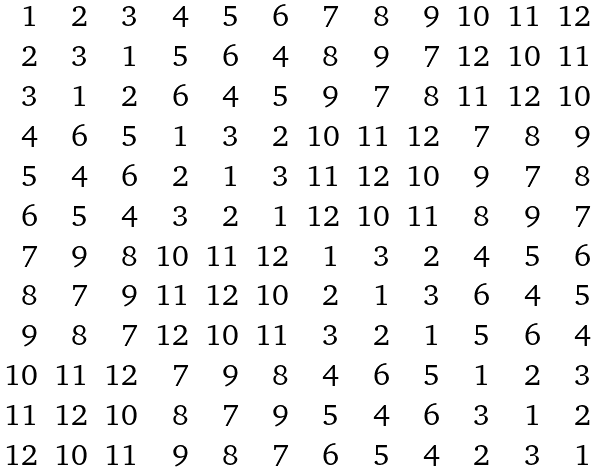Convert formula to latex. <formula><loc_0><loc_0><loc_500><loc_500>\begin{array} { r r r r r r r r r r r r } 1 & 2 & 3 & 4 & 5 & 6 & 7 & 8 & 9 & 1 0 & 1 1 & 1 2 \\ 2 & 3 & 1 & 5 & 6 & 4 & 8 & 9 & 7 & 1 2 & 1 0 & 1 1 \\ 3 & 1 & 2 & 6 & 4 & 5 & 9 & 7 & 8 & 1 1 & 1 2 & 1 0 \\ 4 & 6 & 5 & 1 & 3 & 2 & 1 0 & 1 1 & 1 2 & 7 & 8 & 9 \\ 5 & 4 & 6 & 2 & 1 & 3 & 1 1 & 1 2 & 1 0 & 9 & 7 & 8 \\ 6 & 5 & 4 & 3 & 2 & 1 & 1 2 & 1 0 & 1 1 & 8 & 9 & 7 \\ 7 & 9 & 8 & 1 0 & 1 1 & 1 2 & 1 & 3 & 2 & 4 & 5 & 6 \\ 8 & 7 & 9 & 1 1 & 1 2 & 1 0 & 2 & 1 & 3 & 6 & 4 & 5 \\ 9 & 8 & 7 & 1 2 & 1 0 & 1 1 & 3 & 2 & 1 & 5 & 6 & 4 \\ 1 0 & 1 1 & 1 2 & 7 & 9 & 8 & 4 & 6 & 5 & 1 & 2 & 3 \\ 1 1 & 1 2 & 1 0 & 8 & 7 & 9 & 5 & 4 & 6 & 3 & 1 & 2 \\ 1 2 & 1 0 & 1 1 & 9 & 8 & 7 & 6 & 5 & 4 & 2 & 3 & 1 \end{array}</formula> 